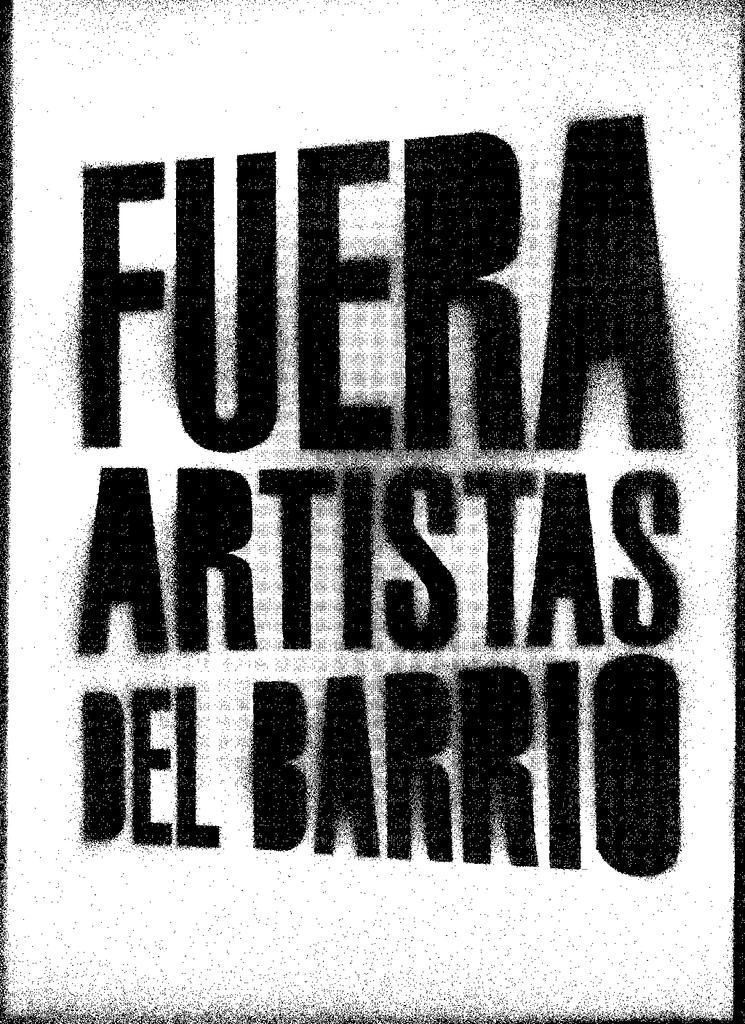<image>
Summarize the visual content of the image. A blank white sheet of paper contains only the words, in thick black fuzzy-edged font, Fuera Artistas Del Barrio. 